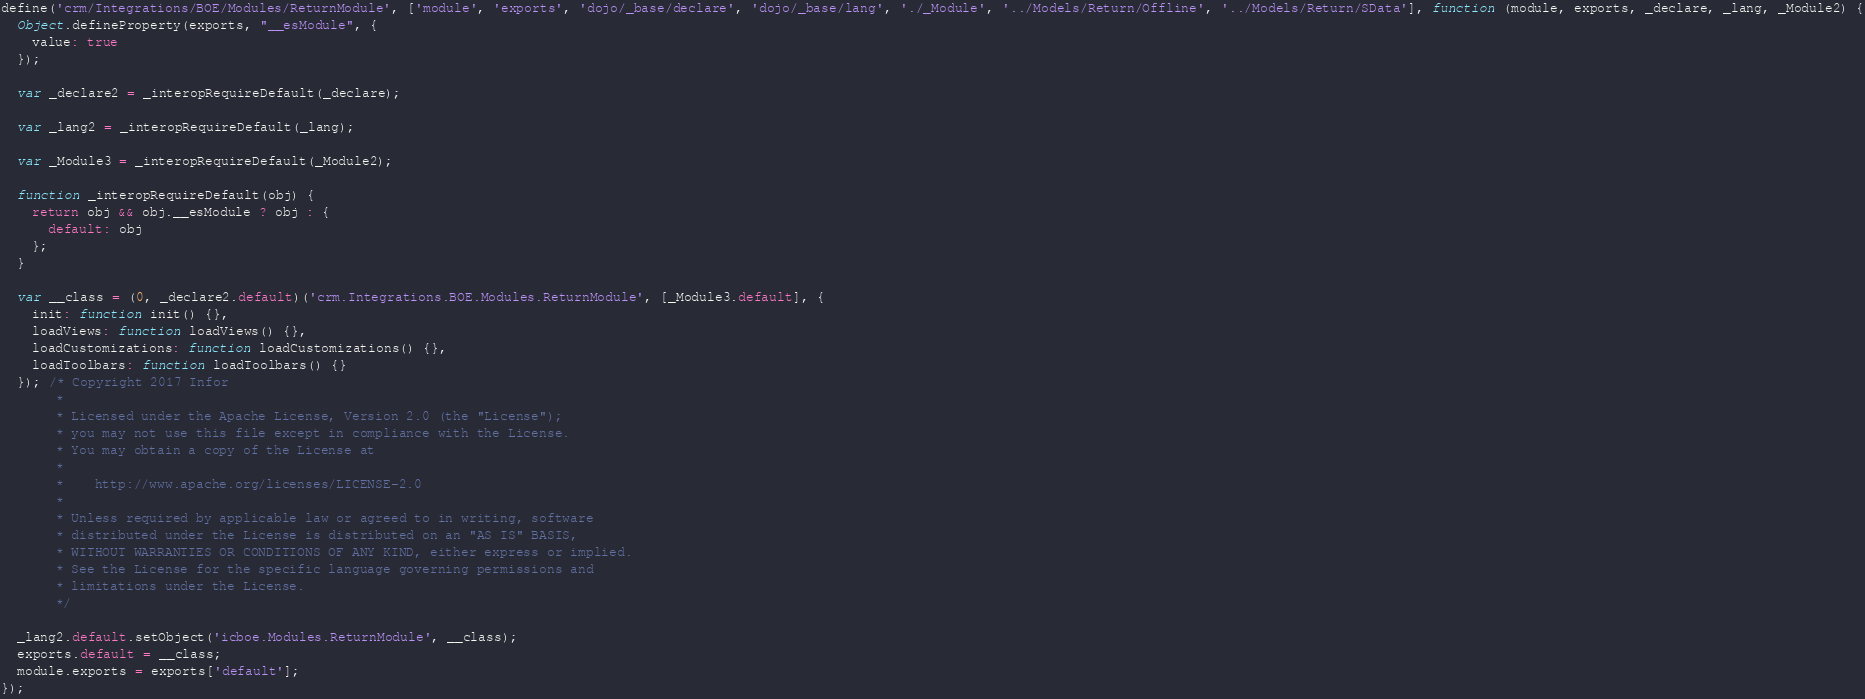<code> <loc_0><loc_0><loc_500><loc_500><_JavaScript_>define('crm/Integrations/BOE/Modules/ReturnModule', ['module', 'exports', 'dojo/_base/declare', 'dojo/_base/lang', './_Module', '../Models/Return/Offline', '../Models/Return/SData'], function (module, exports, _declare, _lang, _Module2) {
  Object.defineProperty(exports, "__esModule", {
    value: true
  });

  var _declare2 = _interopRequireDefault(_declare);

  var _lang2 = _interopRequireDefault(_lang);

  var _Module3 = _interopRequireDefault(_Module2);

  function _interopRequireDefault(obj) {
    return obj && obj.__esModule ? obj : {
      default: obj
    };
  }

  var __class = (0, _declare2.default)('crm.Integrations.BOE.Modules.ReturnModule', [_Module3.default], {
    init: function init() {},
    loadViews: function loadViews() {},
    loadCustomizations: function loadCustomizations() {},
    loadToolbars: function loadToolbars() {}
  }); /* Copyright 2017 Infor
       *
       * Licensed under the Apache License, Version 2.0 (the "License");
       * you may not use this file except in compliance with the License.
       * You may obtain a copy of the License at
       *
       *    http://www.apache.org/licenses/LICENSE-2.0
       *
       * Unless required by applicable law or agreed to in writing, software
       * distributed under the License is distributed on an "AS IS" BASIS,
       * WITHOUT WARRANTIES OR CONDITIONS OF ANY KIND, either express or implied.
       * See the License for the specific language governing permissions and
       * limitations under the License.
       */

  _lang2.default.setObject('icboe.Modules.ReturnModule', __class);
  exports.default = __class;
  module.exports = exports['default'];
});</code> 